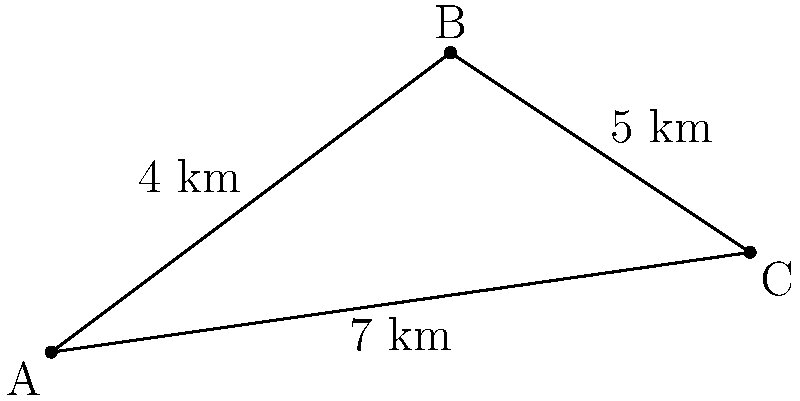As a local business owner offering internships, you want to optimize the commute for your interns. Three interns live at points A, B, and C as shown in the diagram. The distances between their homes are: AB = 4 km, BC = 5 km, and AC = 7 km. If you want to set up a shuttle service that picks up all interns and takes the shortest route to your office (located at point A), what is the total distance the shuttle will travel? To find the optimal path for the shuttle, we need to determine whether it's shorter to go directly from A to C or to go from A to B to C.

Step 1: Calculate the distance of path A-B-C
Distance(A-B-C) = AB + BC = 4 km + 5 km = 9 km

Step 2: Compare with the direct path A-C
Distance(A-C) = 7 km

Step 3: Choose the shorter path
The shorter path is A-C (7 km) rather than A-B-C (9 km)

Step 4: Calculate the total distance
The shuttle needs to go from A to C and then back to A:
Total distance = AC + CA = 7 km + 7 km = 14 km

Therefore, the optimal route for the shuttle is A-C-A, covering a total distance of 14 km.
Answer: 14 km 